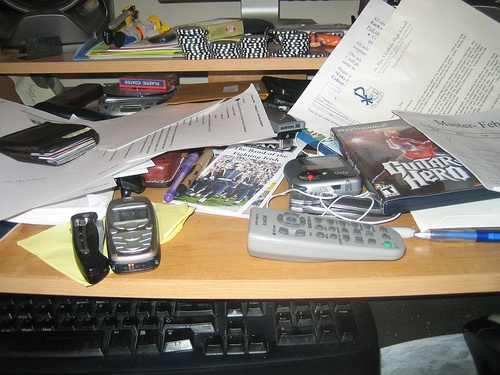Describe the objects in this image and their specific colors. I can see keyboard in black, gray, and darkgray tones, book in black, lightgray, and darkgray tones, remote in black, darkgray, lightgray, and gray tones, book in black, lightgray, gray, and darkgray tones, and cell phone in black, gray, darkgray, and lightgray tones in this image. 